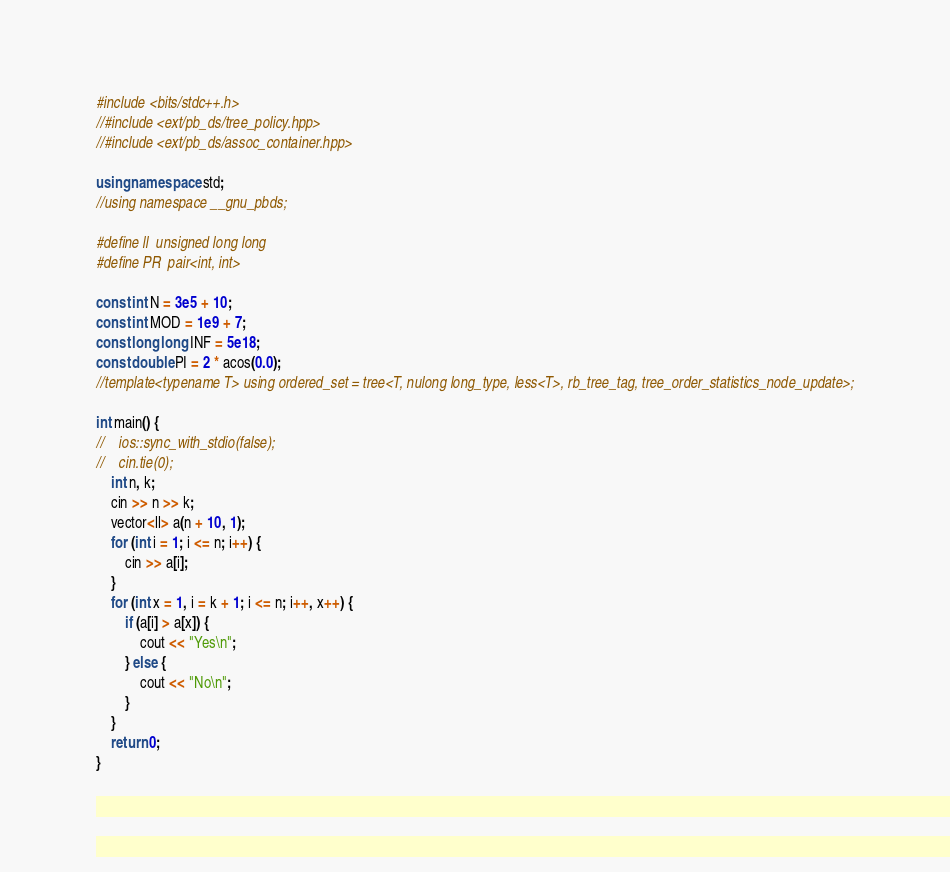<code> <loc_0><loc_0><loc_500><loc_500><_C++_>#include <bits/stdc++.h>
//#include <ext/pb_ds/tree_policy.hpp>
//#include <ext/pb_ds/assoc_container.hpp>

using namespace std;
//using namespace __gnu_pbds;

#define ll  unsigned long long
#define PR  pair<int, int>

const int N = 3e5 + 10;
const int MOD = 1e9 + 7;
const long long INF = 5e18;
const double PI = 2 * acos(0.0);
//template<typename T> using ordered_set = tree<T, nulong long_type, less<T>, rb_tree_tag, tree_order_statistics_node_update>;

int main() {
//    ios::sync_with_stdio(false);
//    cin.tie(0);
    int n, k;
    cin >> n >> k;
    vector<ll> a(n + 10, 1);
    for (int i = 1; i <= n; i++) {
        cin >> a[i];
    }
    for (int x = 1, i = k + 1; i <= n; i++, x++) {
        if (a[i] > a[x]) {
            cout << "Yes\n";
        } else {
            cout << "No\n";
        }
    }
    return 0;
}
</code> 